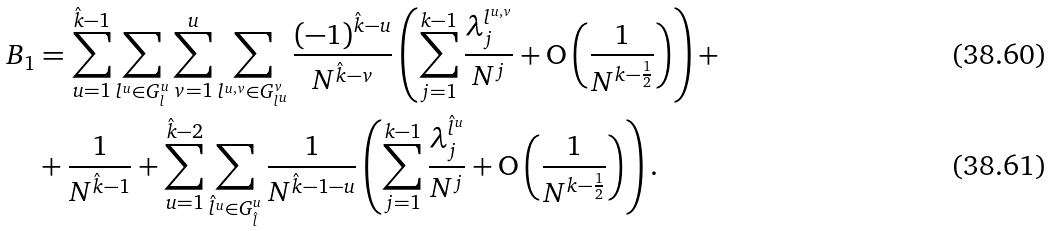Convert formula to latex. <formula><loc_0><loc_0><loc_500><loc_500>B _ { 1 } & = \sum _ { u = 1 } ^ { \hat { k } - 1 } \sum _ { l ^ { u } \in G _ { l } ^ { u } } \sum _ { v = 1 } ^ { u } \sum _ { l ^ { u , v } \in G _ { l ^ { u } } ^ { v } } \frac { ( - 1 ) ^ { \hat { k } - u } } { N ^ { \hat { k } - v } } \left ( \sum _ { j = 1 } ^ { k - 1 } \frac { \lambda _ { j } ^ { l ^ { u , v } } } { N ^ { j } } + \mathrm O \left ( \frac { 1 } { N ^ { k - \frac { 1 } { 2 } } } \right ) \right ) + \\ & + \frac { 1 } { N ^ { \hat { k } - 1 } } + \sum _ { u = 1 } ^ { \hat { k } - 2 } \sum _ { \hat { l } ^ { u } \in G _ { \hat { l } } ^ { u } } \frac { 1 } { N ^ { \hat { k } - 1 - u } } \left ( \sum _ { j = 1 } ^ { k - 1 } \frac { \lambda _ { j } ^ { \hat { l } ^ { u } } } { N ^ { j } } + \mathrm O \left ( \frac { 1 } { N ^ { k - \frac { 1 } { 2 } } } \right ) \right ) .</formula> 